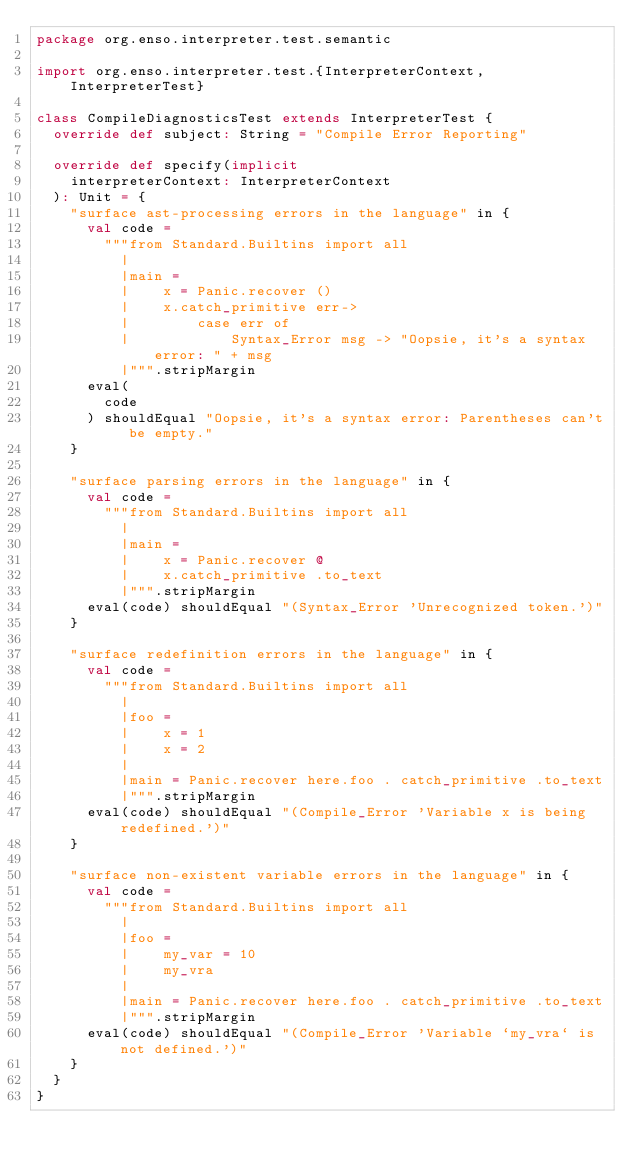<code> <loc_0><loc_0><loc_500><loc_500><_Scala_>package org.enso.interpreter.test.semantic

import org.enso.interpreter.test.{InterpreterContext, InterpreterTest}

class CompileDiagnosticsTest extends InterpreterTest {
  override def subject: String = "Compile Error Reporting"

  override def specify(implicit
    interpreterContext: InterpreterContext
  ): Unit = {
    "surface ast-processing errors in the language" in {
      val code =
        """from Standard.Builtins import all
          |
          |main =
          |    x = Panic.recover ()
          |    x.catch_primitive err->
          |        case err of
          |            Syntax_Error msg -> "Oopsie, it's a syntax error: " + msg
          |""".stripMargin
      eval(
        code
      ) shouldEqual "Oopsie, it's a syntax error: Parentheses can't be empty."
    }

    "surface parsing errors in the language" in {
      val code =
        """from Standard.Builtins import all
          |
          |main =
          |    x = Panic.recover @
          |    x.catch_primitive .to_text
          |""".stripMargin
      eval(code) shouldEqual "(Syntax_Error 'Unrecognized token.')"
    }

    "surface redefinition errors in the language" in {
      val code =
        """from Standard.Builtins import all
          |
          |foo =
          |    x = 1
          |    x = 2
          |
          |main = Panic.recover here.foo . catch_primitive .to_text
          |""".stripMargin
      eval(code) shouldEqual "(Compile_Error 'Variable x is being redefined.')"
    }

    "surface non-existent variable errors in the language" in {
      val code =
        """from Standard.Builtins import all
          |
          |foo =
          |    my_var = 10
          |    my_vra
          |
          |main = Panic.recover here.foo . catch_primitive .to_text
          |""".stripMargin
      eval(code) shouldEqual "(Compile_Error 'Variable `my_vra` is not defined.')"
    }
  }
}
</code> 